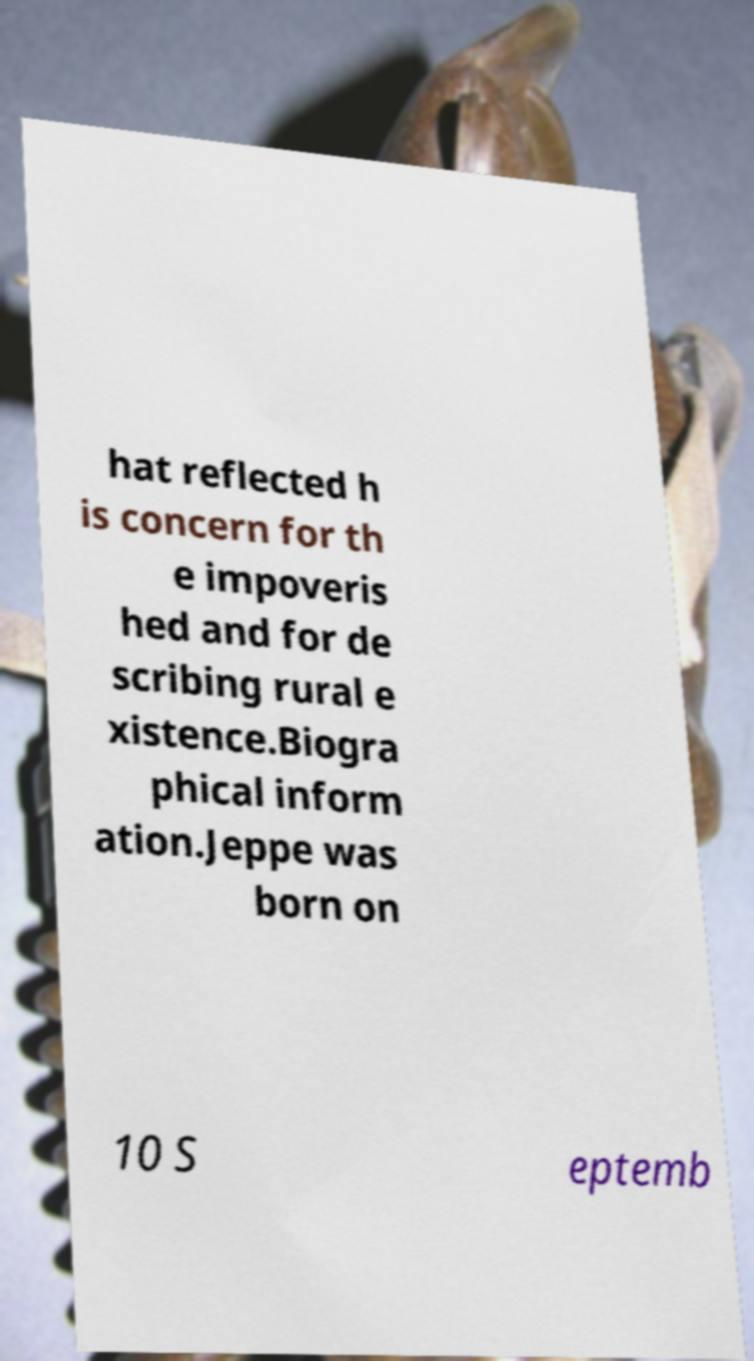For documentation purposes, I need the text within this image transcribed. Could you provide that? hat reflected h is concern for th e impoveris hed and for de scribing rural e xistence.Biogra phical inform ation.Jeppe was born on 10 S eptemb 